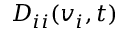<formula> <loc_0><loc_0><loc_500><loc_500>D _ { i i } ( v _ { i } , t )</formula> 